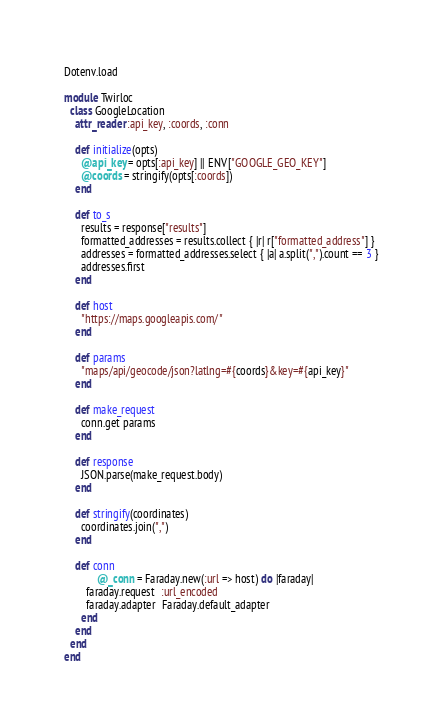Convert code to text. <code><loc_0><loc_0><loc_500><loc_500><_Ruby_>Dotenv.load

module Twirloc
  class GoogleLocation
    attr_reader :api_key, :coords, :conn

    def initialize(opts)
      @api_key = opts[:api_key] || ENV["GOOGLE_GEO_KEY"]
      @coords = stringify(opts[:coords])
    end

    def to_s
      results = response["results"]
      formatted_addresses = results.collect { |r| r["formatted_address"] }
      addresses = formatted_addresses.select { |a| a.split(",").count == 3 }
      addresses.first
    end

    def host
      "https://maps.googleapis.com/"
    end

    def params
      "maps/api/geocode/json?latlng=#{coords}&key=#{api_key}"
    end

    def make_request
      conn.get params
    end

    def response
      JSON.parse(make_request.body)
    end

    def stringify(coordinates)
      coordinates.join(",")
    end

    def conn
			@_conn = Faraday.new(:url => host) do |faraday|
        faraday.request  :url_encoded
        faraday.adapter  Faraday.default_adapter
      end
    end
  end
end
</code> 